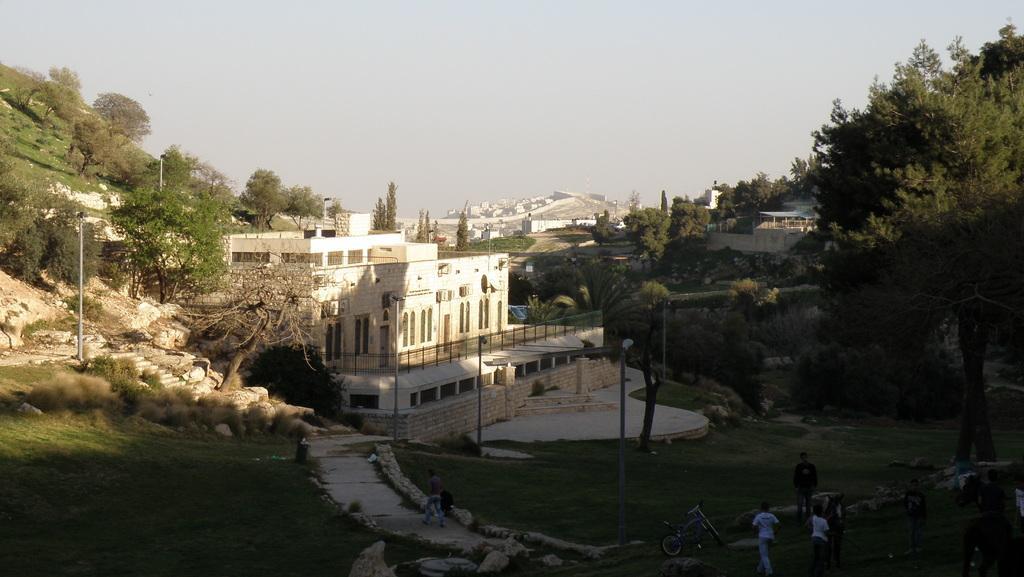Describe this image in one or two sentences. In this image we can see a building with windows and a fence. We can also see some poles, a group of trees, a staircase, grass, a group of buildings and the sky which looks cloudy. On the bottom of the image we can see a group of people standing, some stones, a bicycle and a person walking on the pathway. 